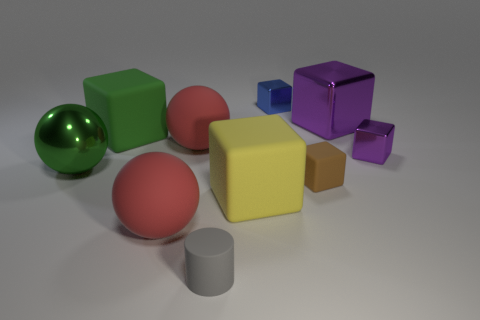Is there a brown matte sphere that has the same size as the green rubber cube?
Your response must be concise. No. What number of tiny purple shiny objects are the same shape as the blue object?
Provide a short and direct response. 1. Is the number of large shiny spheres that are behind the small brown rubber block the same as the number of brown things that are in front of the gray cylinder?
Offer a very short reply. No. Is there a yellow metal object?
Your answer should be very brief. No. What is the size of the purple shiny block that is in front of the big matte block on the left side of the red sphere that is in front of the green shiny ball?
Provide a succinct answer. Small. What shape is the matte thing that is the same size as the cylinder?
Keep it short and to the point. Cube. Is there any other thing that has the same material as the green ball?
Give a very brief answer. Yes. What number of things are either blocks that are behind the small purple shiny thing or large matte cubes?
Give a very brief answer. 4. There is a small block to the right of the small brown cube that is on the right side of the green matte cube; is there a big sphere that is in front of it?
Your answer should be very brief. Yes. What number of gray matte things are there?
Ensure brevity in your answer.  1. 